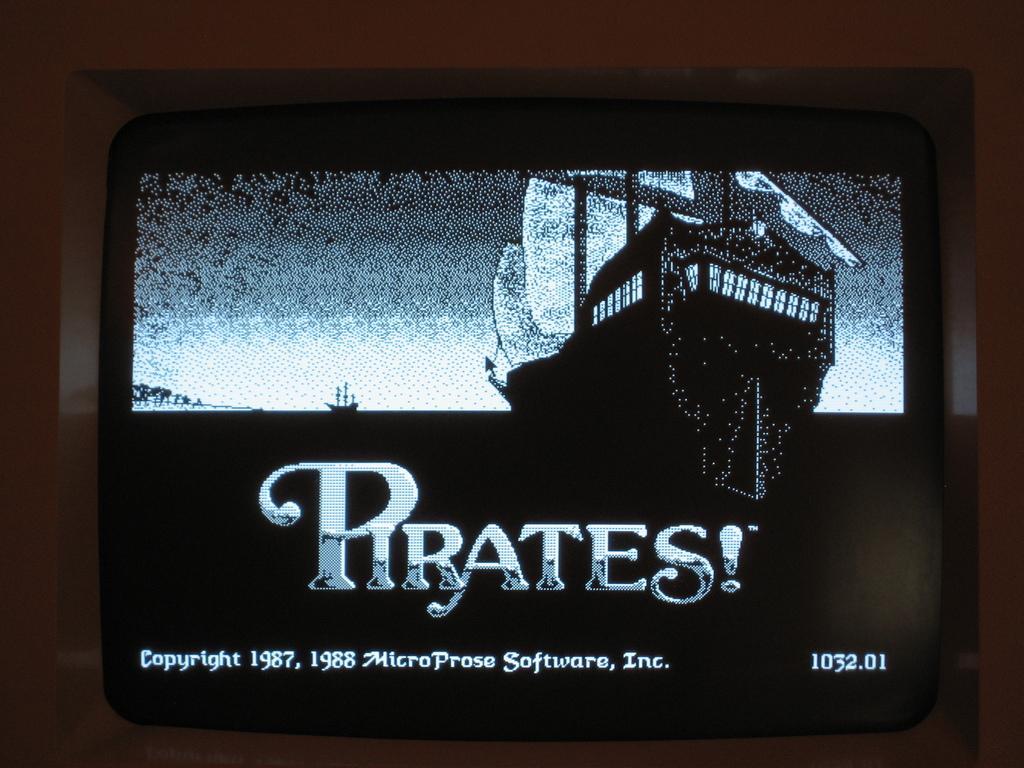How would you summarize this image in a sentence or two? In this image we can see a screen on which we can see some ships and some text on it. 